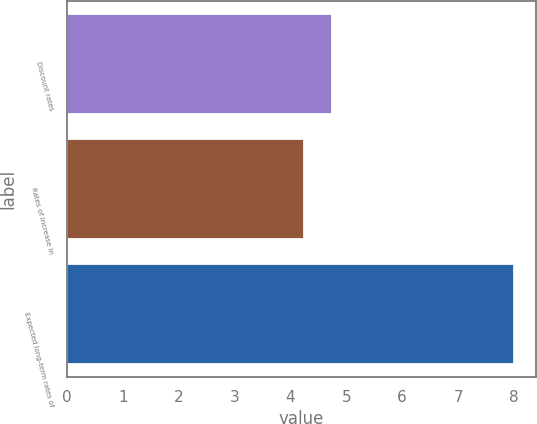<chart> <loc_0><loc_0><loc_500><loc_500><bar_chart><fcel>Discount rates<fcel>Rates of increase in<fcel>Expected long-term rates of<nl><fcel>4.75<fcel>4.25<fcel>8<nl></chart> 